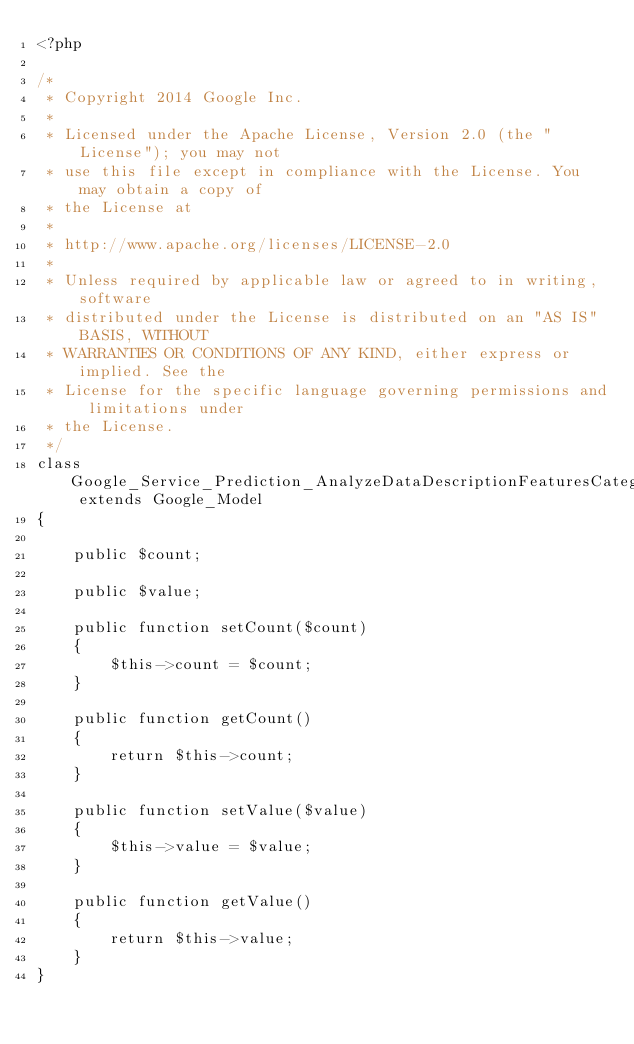Convert code to text. <code><loc_0><loc_0><loc_500><loc_500><_PHP_><?php

/*
 * Copyright 2014 Google Inc.
 *
 * Licensed under the Apache License, Version 2.0 (the "License"); you may not
 * use this file except in compliance with the License. You may obtain a copy of
 * the License at
 *
 * http://www.apache.org/licenses/LICENSE-2.0
 *
 * Unless required by applicable law or agreed to in writing, software
 * distributed under the License is distributed on an "AS IS" BASIS, WITHOUT
 * WARRANTIES OR CONDITIONS OF ANY KIND, either express or implied. See the
 * License for the specific language governing permissions and limitations under
 * the License.
 */
class Google_Service_Prediction_AnalyzeDataDescriptionFeaturesCategoricalValues extends Google_Model
{

    public $count;

    public $value;

    public function setCount($count)
    {
        $this->count = $count;
    }

    public function getCount()
    {
        return $this->count;
    }

    public function setValue($value)
    {
        $this->value = $value;
    }

    public function getValue()
    {
        return $this->value;
    }
}
</code> 